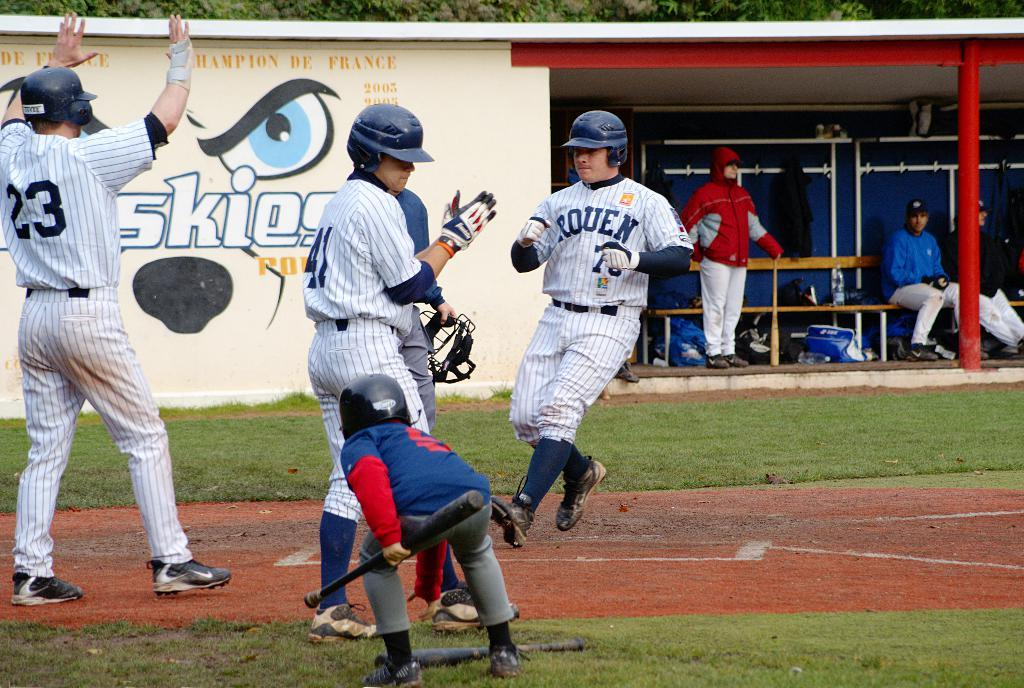<image>
Provide a brief description of the given image. On the back of a baseball uniform worn by number 23 a man can be seen holding his hands up. 